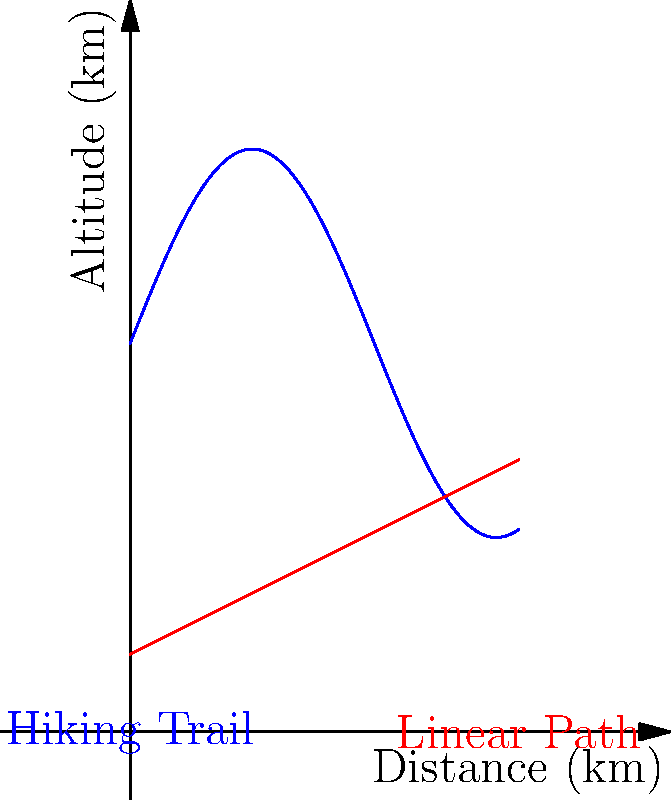A budget-conscious backpacker is planning a hiking trip along a trail represented by the blue curve in the graph. The red line represents a hypothetical linear path between the same start and end points. The x-axis represents the horizontal distance traveled, and the y-axis represents the altitude.

Given that the blue curve is described by the function $f(x) = 5\sin(\frac{x}{2}) + 10$ and the red line by $g(x) = 2 + 0.5x$, where $x$ is in kilometers and $f(x)$ and $g(x)$ are in kilometers:

1) At what horizontal distance $x$ is the rate of change in altitude of the actual hiking trail (blue curve) equal to the constant rate of change of the linear path (red line)?

2) What is this rate of change? Let's approach this step-by-step:

1) The rate of change for the linear path (red line) is its slope, which is 0.5 km/km or 0.5.

2) For the hiking trail (blue curve), the rate of change at any point is given by its derivative:
   $f'(x) = 5 \cdot \frac{1}{2} \cos(\frac{x}{2}) = \frac{5}{2} \cos(\frac{x}{2})$

3) We want to find where this rate equals 0.5:
   $\frac{5}{2} \cos(\frac{x}{2}) = 0.5$

4) Solving this equation:
   $\cos(\frac{x}{2}) = \frac{1}{5}$
   $\frac{x}{2} = \arccos(\frac{1}{5})$
   $x = 2 \arccos(\frac{1}{5}) \approx 2.214$ km

5) To verify the rate of change at this point:
   $f'(2.214) = \frac{5}{2} \cos(\frac{2.214}{2}) = \frac{5}{2} \cdot \frac{1}{5} = 0.5$

Therefore, at approximately 2.214 km horizontal distance, the rate of change of altitude for the hiking trail equals the constant rate of change of the linear path, which is 0.5 km/km.
Answer: 1) $x = 2 \arccos(\frac{1}{5}) \approx 2.214$ km
2) 0.5 km/km 